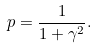<formula> <loc_0><loc_0><loc_500><loc_500>p = \frac { 1 } { 1 + \gamma ^ { 2 } } .</formula> 